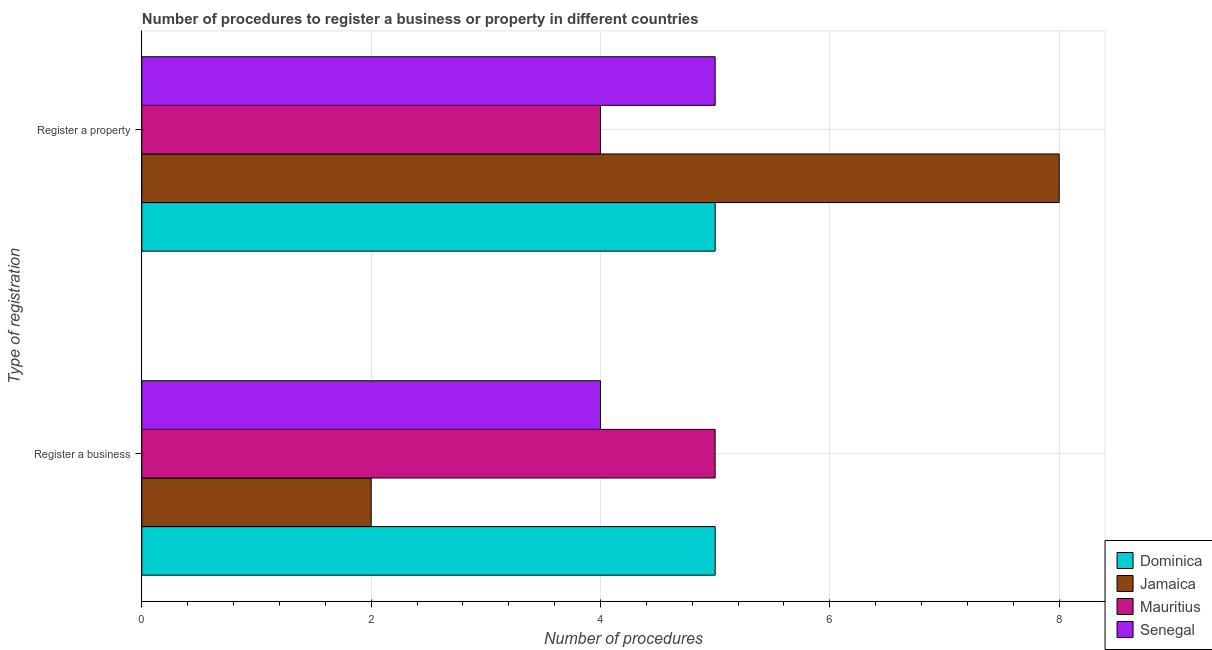How many different coloured bars are there?
Your answer should be very brief. 4. Are the number of bars per tick equal to the number of legend labels?
Offer a terse response. Yes. Are the number of bars on each tick of the Y-axis equal?
Your response must be concise. Yes. How many bars are there on the 2nd tick from the bottom?
Your answer should be very brief. 4. What is the label of the 1st group of bars from the top?
Your answer should be very brief. Register a property. What is the number of procedures to register a business in Mauritius?
Give a very brief answer. 5. Across all countries, what is the maximum number of procedures to register a business?
Provide a short and direct response. 5. Across all countries, what is the minimum number of procedures to register a property?
Offer a terse response. 4. In which country was the number of procedures to register a business maximum?
Your response must be concise. Dominica. In which country was the number of procedures to register a business minimum?
Offer a terse response. Jamaica. What is the total number of procedures to register a property in the graph?
Your answer should be very brief. 22. What is the difference between the number of procedures to register a business in Jamaica and that in Senegal?
Offer a very short reply. -2. What is the difference between the number of procedures to register a property in Jamaica and the number of procedures to register a business in Senegal?
Offer a terse response. 4. What is the difference between the number of procedures to register a business and number of procedures to register a property in Jamaica?
Provide a succinct answer. -6. In how many countries, is the number of procedures to register a business greater than 2.8 ?
Provide a short and direct response. 3. What is the ratio of the number of procedures to register a property in Dominica to that in Jamaica?
Your answer should be very brief. 0.62. Is the number of procedures to register a business in Dominica less than that in Senegal?
Offer a terse response. No. What does the 3rd bar from the top in Register a property represents?
Offer a terse response. Jamaica. What does the 3rd bar from the bottom in Register a property represents?
Your answer should be compact. Mauritius. How many bars are there?
Keep it short and to the point. 8. Are all the bars in the graph horizontal?
Your answer should be very brief. Yes. What is the difference between two consecutive major ticks on the X-axis?
Give a very brief answer. 2. Does the graph contain any zero values?
Keep it short and to the point. No. How many legend labels are there?
Provide a succinct answer. 4. How are the legend labels stacked?
Ensure brevity in your answer.  Vertical. What is the title of the graph?
Offer a terse response. Number of procedures to register a business or property in different countries. What is the label or title of the X-axis?
Offer a very short reply. Number of procedures. What is the label or title of the Y-axis?
Keep it short and to the point. Type of registration. What is the Number of procedures in Dominica in Register a business?
Offer a very short reply. 5. What is the Number of procedures of Jamaica in Register a business?
Provide a short and direct response. 2. What is the Number of procedures of Jamaica in Register a property?
Keep it short and to the point. 8. What is the Number of procedures of Senegal in Register a property?
Ensure brevity in your answer.  5. Across all Type of registration, what is the maximum Number of procedures of Dominica?
Ensure brevity in your answer.  5. Across all Type of registration, what is the minimum Number of procedures of Dominica?
Ensure brevity in your answer.  5. Across all Type of registration, what is the minimum Number of procedures of Jamaica?
Your answer should be compact. 2. What is the total Number of procedures in Dominica in the graph?
Ensure brevity in your answer.  10. What is the total Number of procedures in Senegal in the graph?
Keep it short and to the point. 9. What is the difference between the Number of procedures of Dominica in Register a business and that in Register a property?
Your answer should be very brief. 0. What is the difference between the Number of procedures in Jamaica in Register a business and that in Register a property?
Your answer should be compact. -6. What is the difference between the Number of procedures of Mauritius in Register a business and that in Register a property?
Provide a succinct answer. 1. What is the difference between the Number of procedures of Senegal in Register a business and that in Register a property?
Your answer should be compact. -1. What is the difference between the Number of procedures of Dominica in Register a business and the Number of procedures of Jamaica in Register a property?
Ensure brevity in your answer.  -3. What is the difference between the Number of procedures in Dominica in Register a business and the Number of procedures in Mauritius in Register a property?
Give a very brief answer. 1. What is the difference between the Number of procedures in Jamaica in Register a business and the Number of procedures in Senegal in Register a property?
Ensure brevity in your answer.  -3. What is the difference between the Number of procedures of Mauritius in Register a business and the Number of procedures of Senegal in Register a property?
Provide a succinct answer. 0. What is the average Number of procedures of Dominica per Type of registration?
Ensure brevity in your answer.  5. What is the average Number of procedures of Senegal per Type of registration?
Keep it short and to the point. 4.5. What is the difference between the Number of procedures in Dominica and Number of procedures in Jamaica in Register a business?
Offer a terse response. 3. What is the difference between the Number of procedures of Jamaica and Number of procedures of Senegal in Register a business?
Ensure brevity in your answer.  -2. What is the difference between the Number of procedures of Dominica and Number of procedures of Jamaica in Register a property?
Ensure brevity in your answer.  -3. What is the difference between the Number of procedures of Dominica and Number of procedures of Senegal in Register a property?
Provide a short and direct response. 0. What is the difference between the Number of procedures in Mauritius and Number of procedures in Senegal in Register a property?
Provide a succinct answer. -1. What is the ratio of the Number of procedures of Jamaica in Register a business to that in Register a property?
Make the answer very short. 0.25. What is the ratio of the Number of procedures of Mauritius in Register a business to that in Register a property?
Offer a very short reply. 1.25. What is the ratio of the Number of procedures in Senegal in Register a business to that in Register a property?
Your answer should be very brief. 0.8. What is the difference between the highest and the second highest Number of procedures of Dominica?
Offer a very short reply. 0. What is the difference between the highest and the second highest Number of procedures in Jamaica?
Offer a very short reply. 6. What is the difference between the highest and the second highest Number of procedures in Senegal?
Your answer should be compact. 1. What is the difference between the highest and the lowest Number of procedures of Dominica?
Ensure brevity in your answer.  0. What is the difference between the highest and the lowest Number of procedures of Jamaica?
Offer a terse response. 6. 